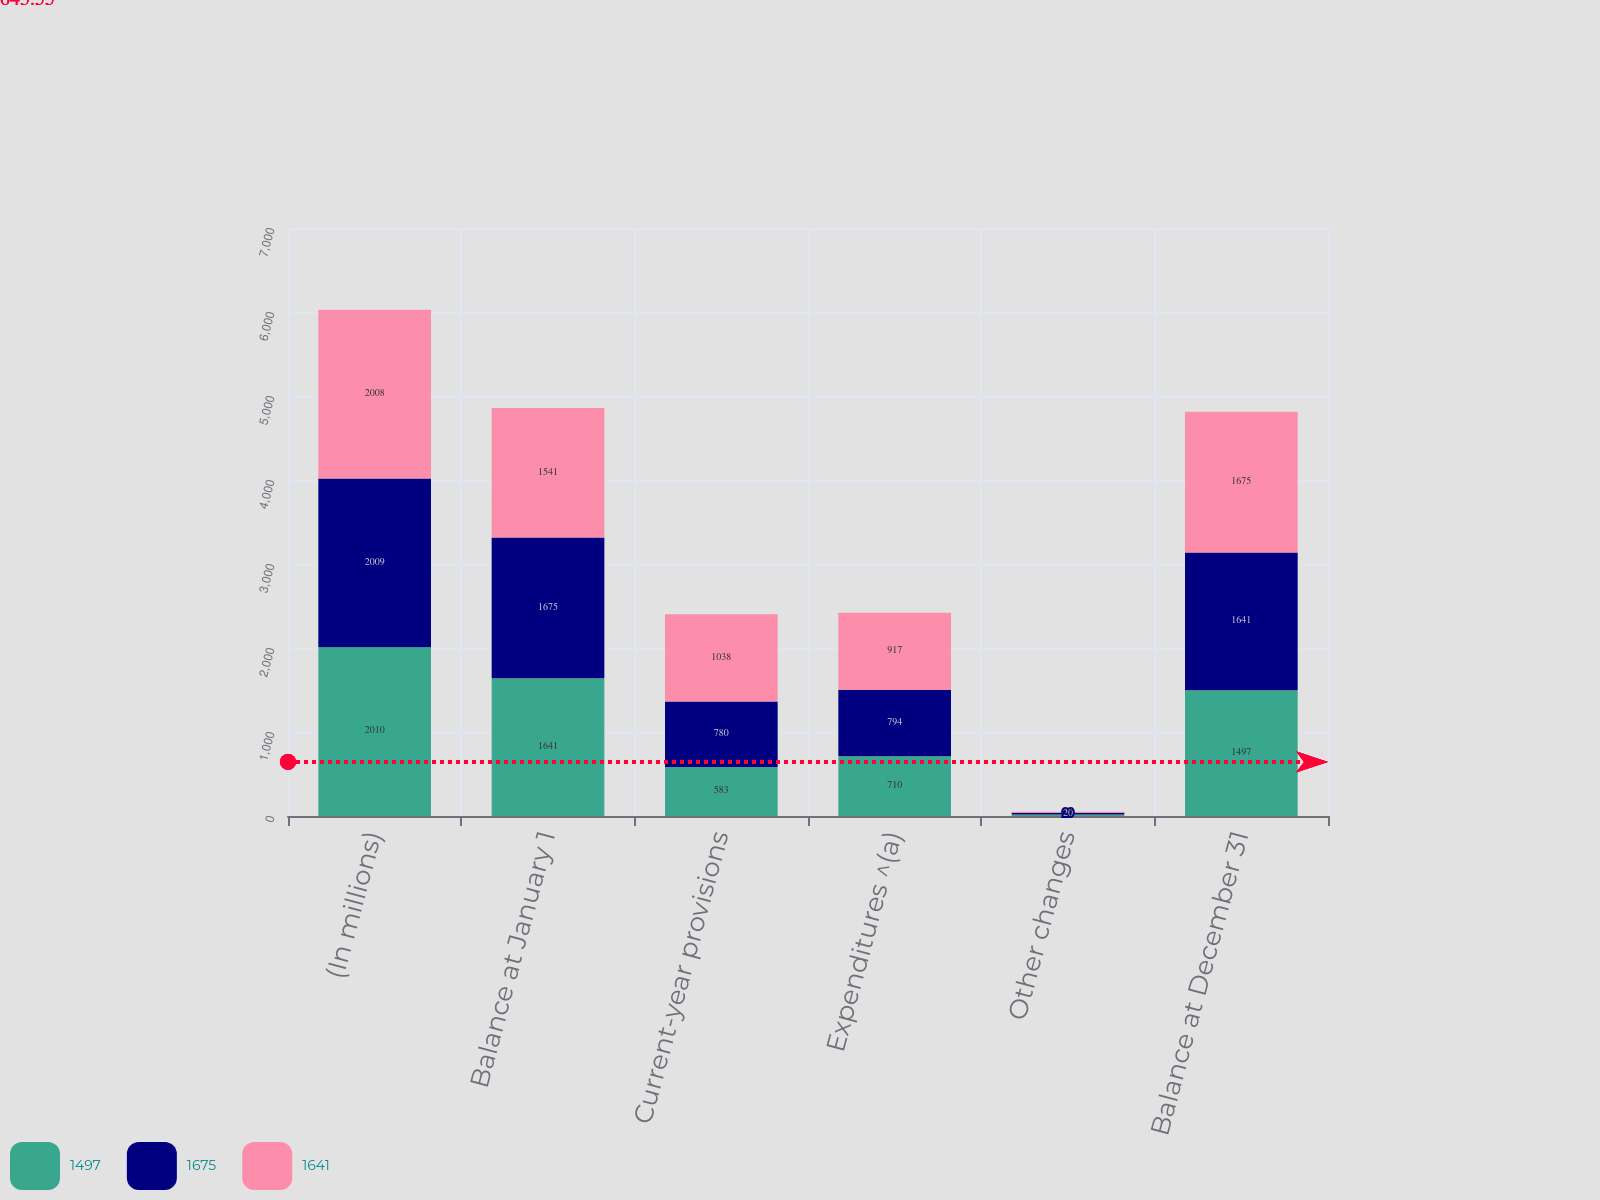Convert chart. <chart><loc_0><loc_0><loc_500><loc_500><stacked_bar_chart><ecel><fcel>(In millions)<fcel>Balance at January 1<fcel>Current-year provisions<fcel>Expenditures ^(a)<fcel>Other changes<fcel>Balance at December 31<nl><fcel>1497<fcel>2010<fcel>1641<fcel>583<fcel>710<fcel>17<fcel>1497<nl><fcel>1675<fcel>2009<fcel>1675<fcel>780<fcel>794<fcel>20<fcel>1641<nl><fcel>1641<fcel>2008<fcel>1541<fcel>1038<fcel>917<fcel>13<fcel>1675<nl></chart> 